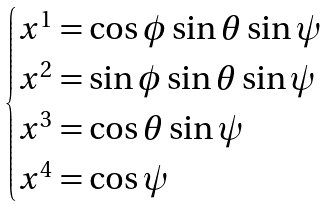Convert formula to latex. <formula><loc_0><loc_0><loc_500><loc_500>\begin{cases} x ^ { 1 } = \cos \phi \sin \theta \sin \psi \\ x ^ { 2 } = \sin \phi \sin \theta \sin \psi \\ x ^ { 3 } = \cos \theta \sin \psi \\ x ^ { 4 } = \cos \psi \end{cases}</formula> 